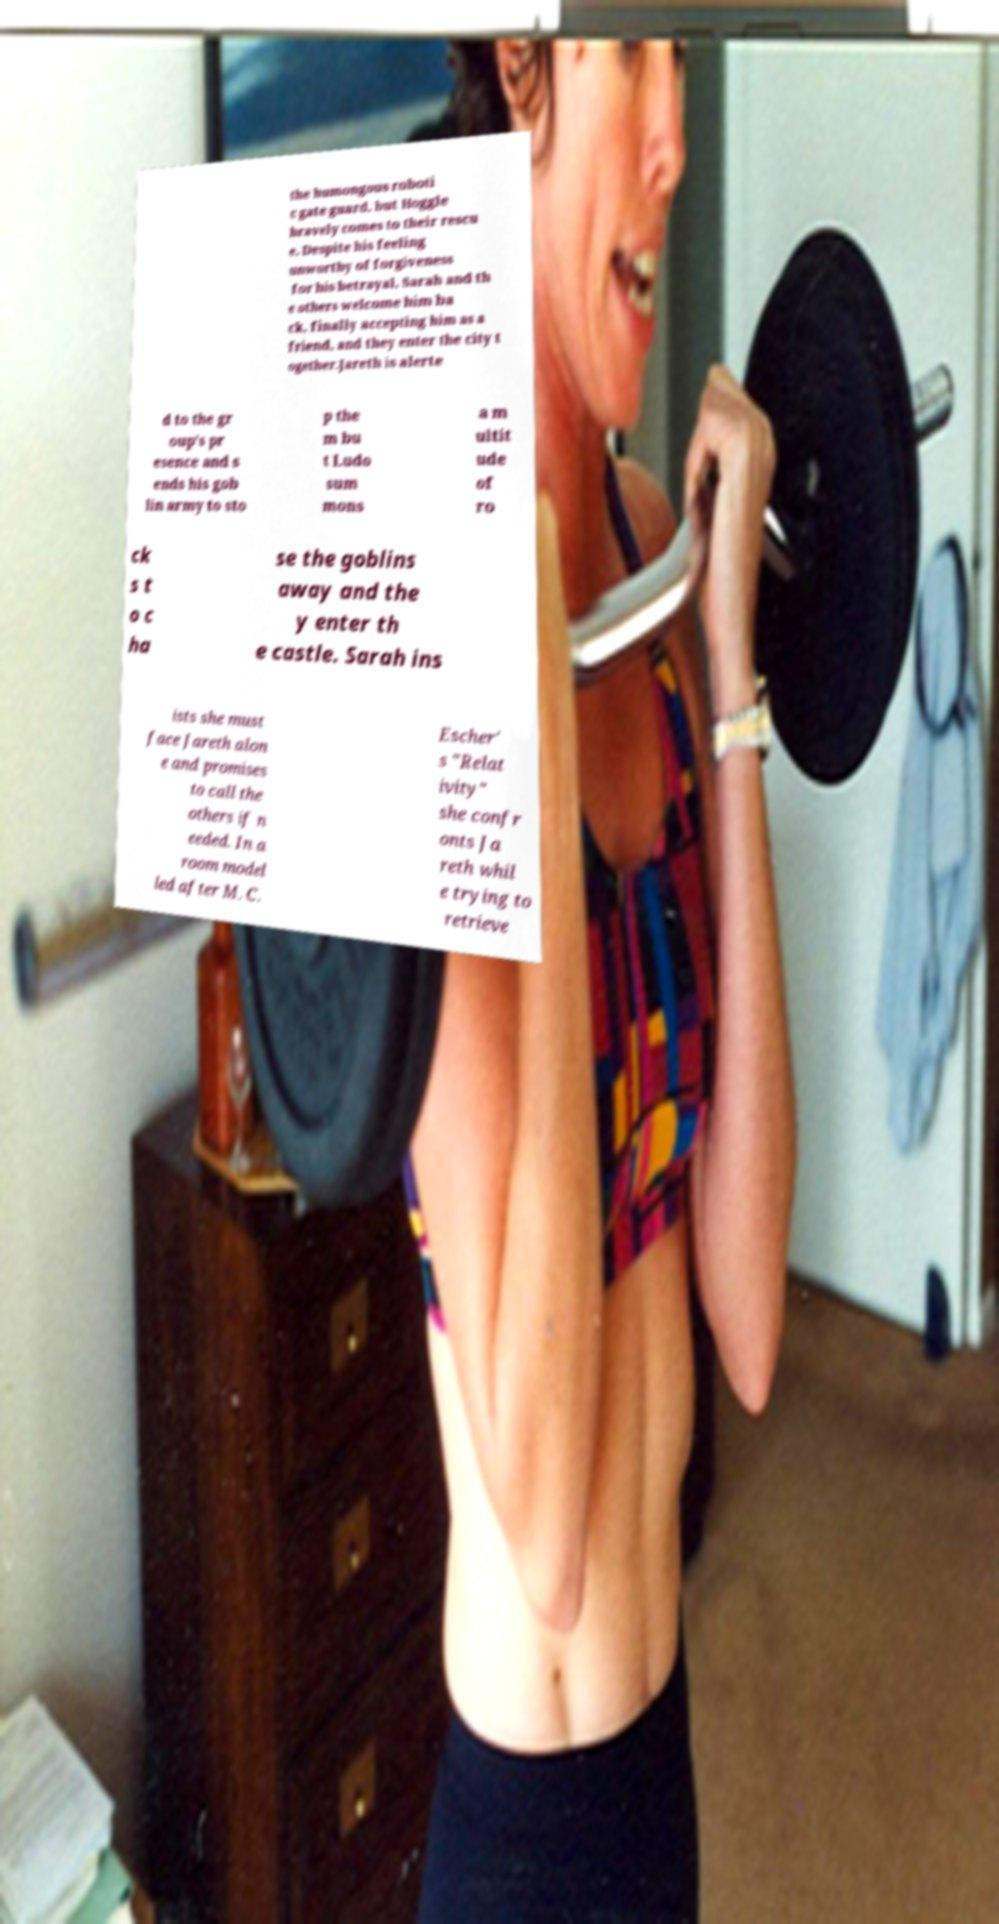What messages or text are displayed in this image? I need them in a readable, typed format. the humongous roboti c gate guard, but Hoggle bravely comes to their rescu e. Despite his feeling unworthy of forgiveness for his betrayal, Sarah and th e others welcome him ba ck, finally accepting him as a friend, and they enter the city t ogether.Jareth is alerte d to the gr oup's pr esence and s ends his gob lin army to sto p the m bu t Ludo sum mons a m ultit ude of ro ck s t o c ha se the goblins away and the y enter th e castle. Sarah ins ists she must face Jareth alon e and promises to call the others if n eeded. In a room model led after M. C. Escher' s "Relat ivity" she confr onts Ja reth whil e trying to retrieve 